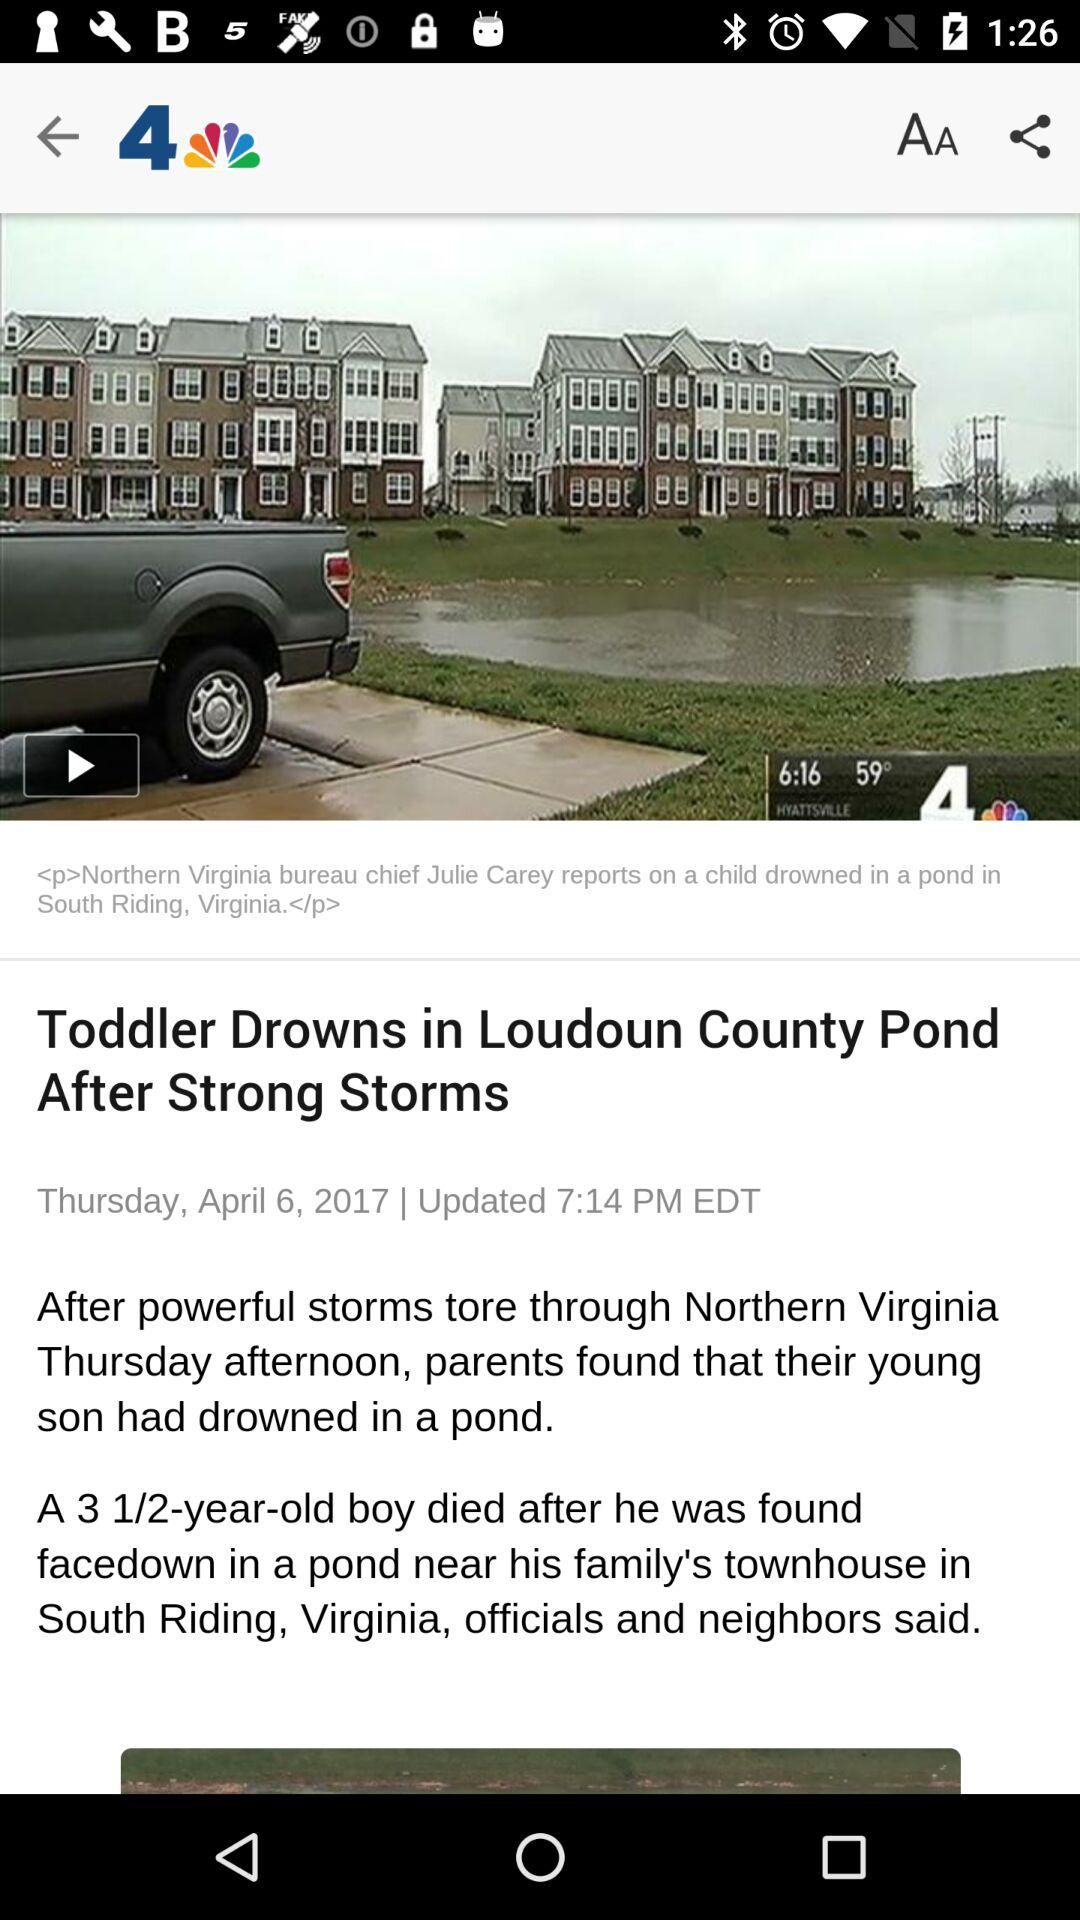What is the publication date? The publication date is Thursday, April 6, 2017. 